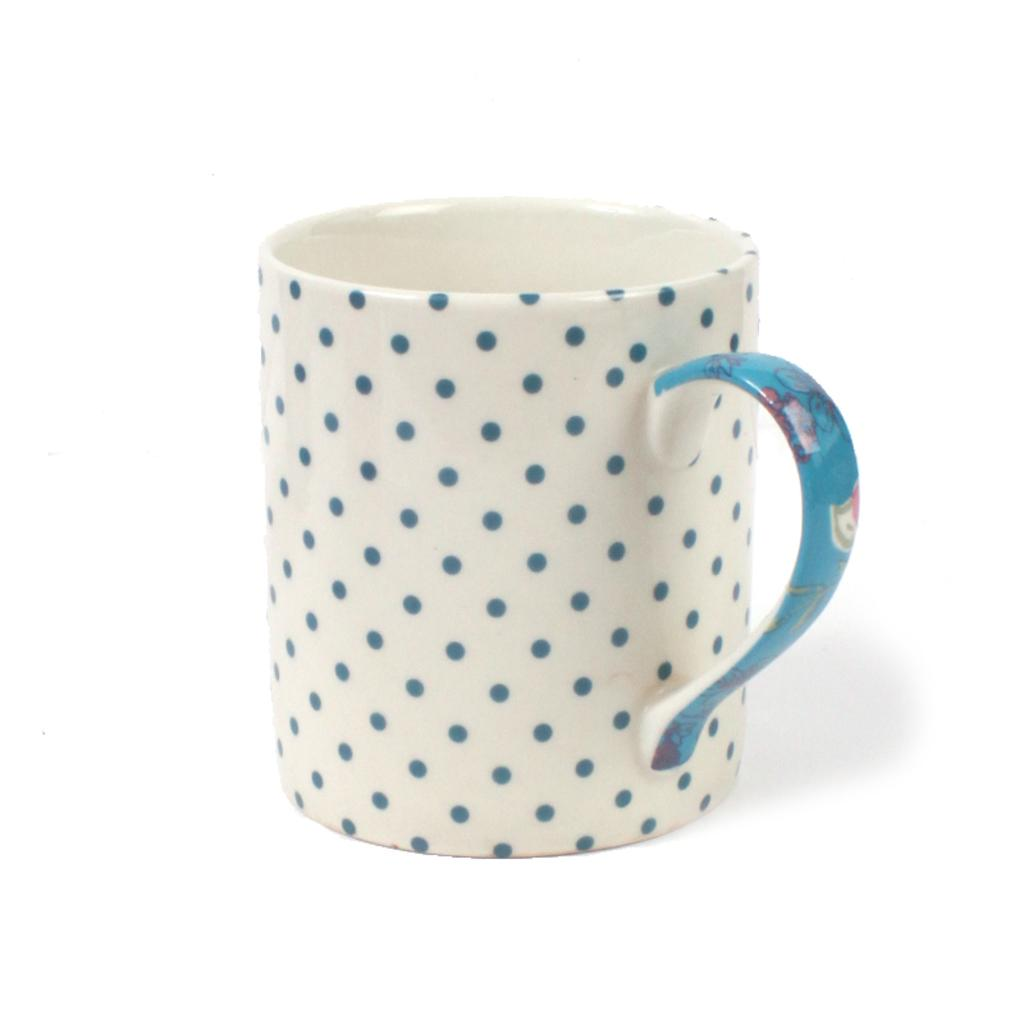What is present in the image? There is a cup in the image. Can you describe the appearance of the cup? The cup has dots on it. How many matches are in the cup in the image? There are no matches present in the image; it only contains a cup with dots on it. 